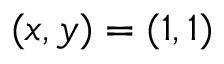Convert formula to latex. <formula><loc_0><loc_0><loc_500><loc_500>( x , y ) = ( 1 , 1 )</formula> 